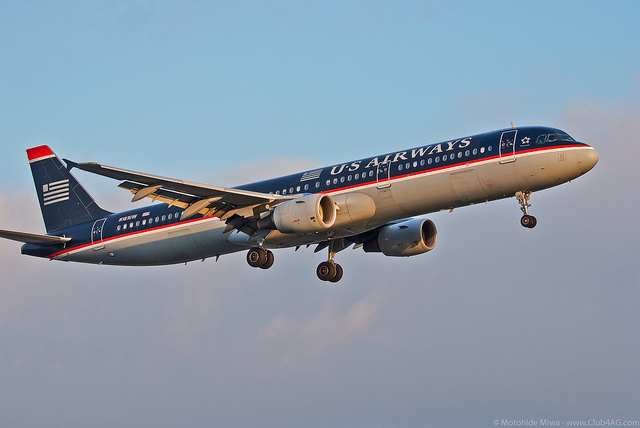Please identify all text content in this image. U.S AIRWAYS 